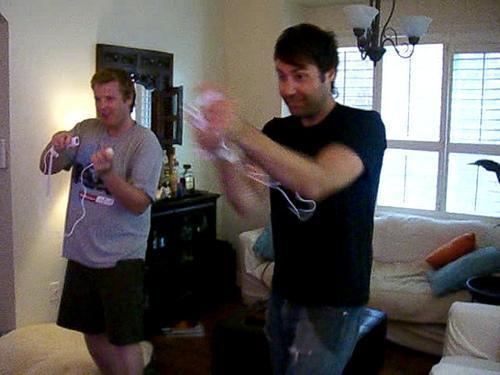How many people are there?
Give a very brief answer. 2. 